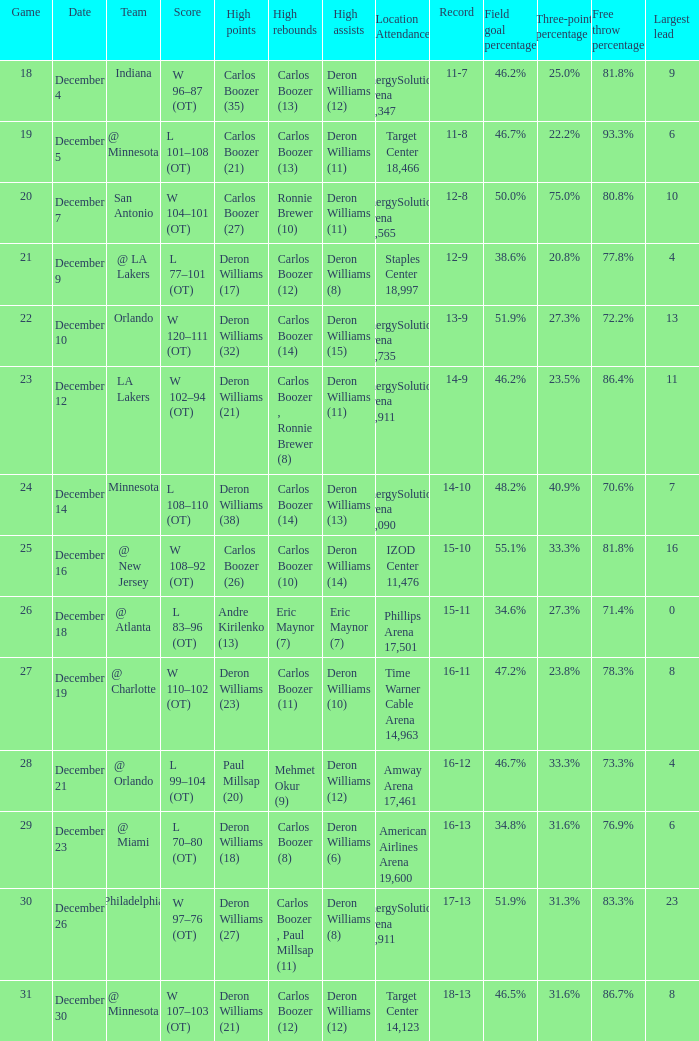How many different high rebound results are there for the game number 26? 1.0. 